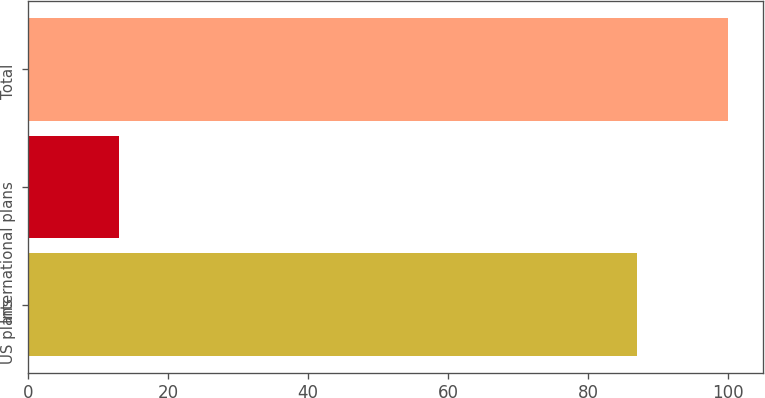<chart> <loc_0><loc_0><loc_500><loc_500><bar_chart><fcel>US plans<fcel>International plans<fcel>Total<nl><fcel>87<fcel>13<fcel>100<nl></chart> 